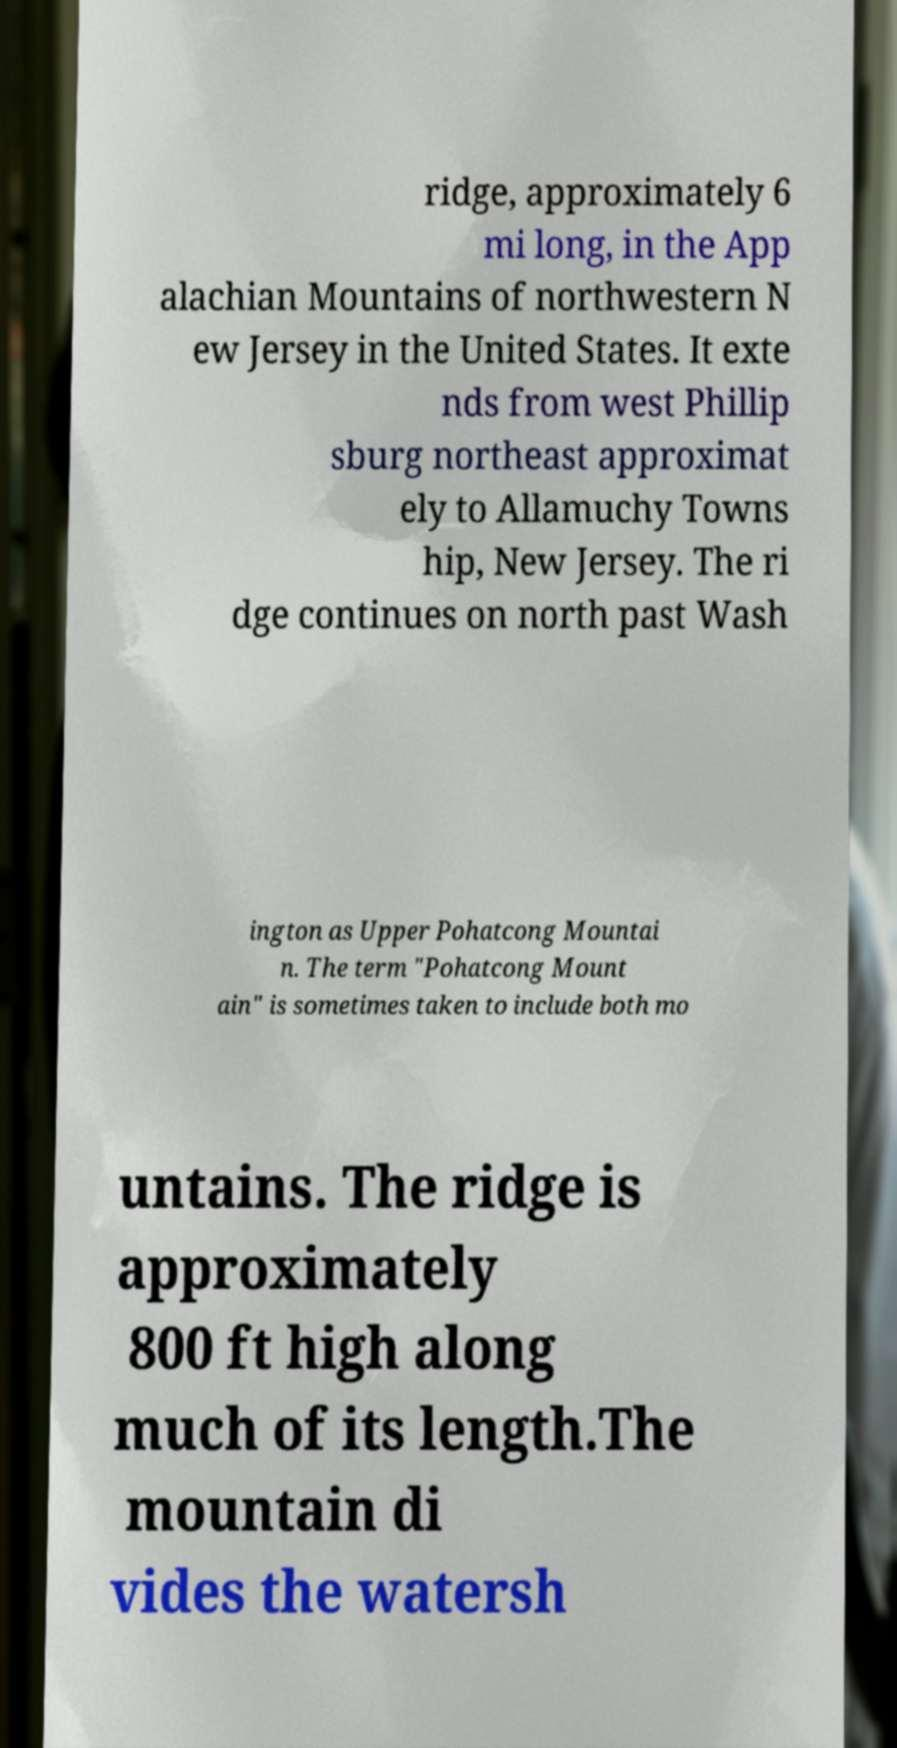Can you accurately transcribe the text from the provided image for me? ridge, approximately 6 mi long, in the App alachian Mountains of northwestern N ew Jersey in the United States. It exte nds from west Phillip sburg northeast approximat ely to Allamuchy Towns hip, New Jersey. The ri dge continues on north past Wash ington as Upper Pohatcong Mountai n. The term "Pohatcong Mount ain" is sometimes taken to include both mo untains. The ridge is approximately 800 ft high along much of its length.The mountain di vides the watersh 